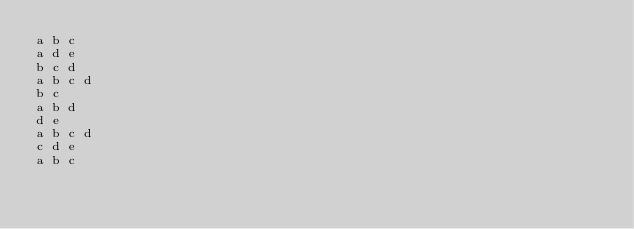<code> <loc_0><loc_0><loc_500><loc_500><_SQL_>a b c
a d e
b c d
a b c d
b c
a b d
d e
a b c d
c d e
a b c
</code> 